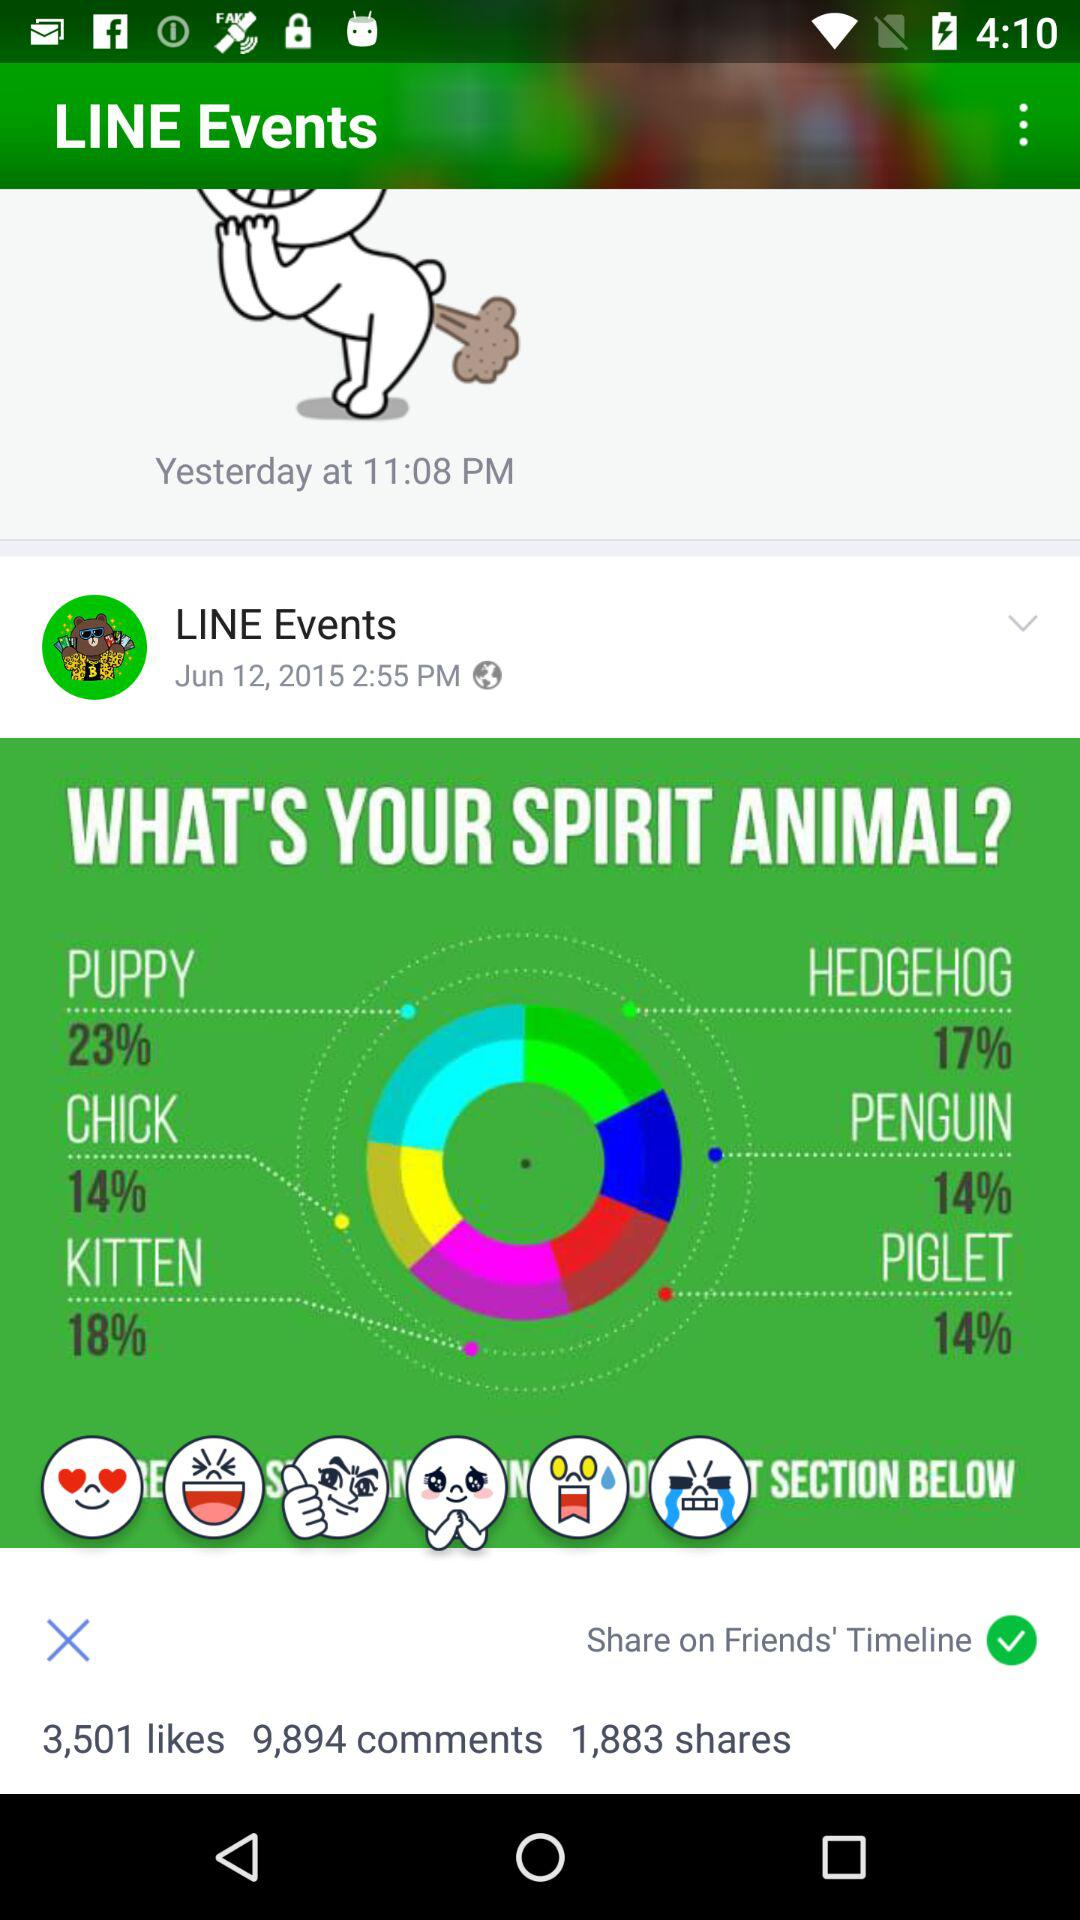How many comments are there? There are 9,894 comments. 